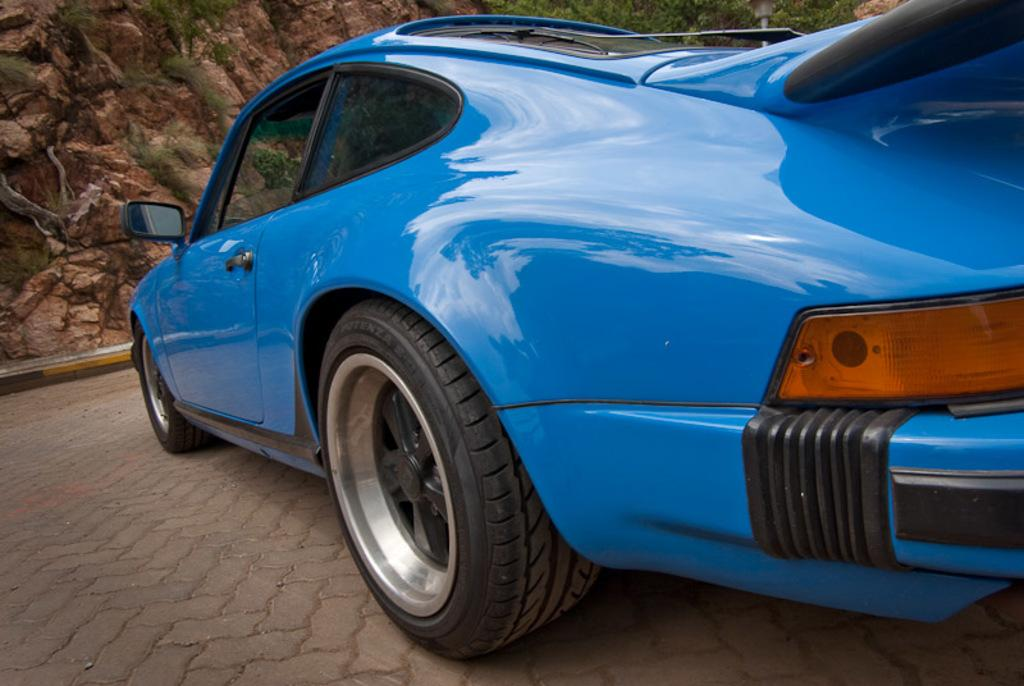What is the main subject of the image? There is a car on the road in the image. What can be seen in the background of the image? There are rocks and trees in the background of the image. How many socks can be seen on the car in the image? There are no socks present in the image; it features a car on the road with rocks and trees in the background. 